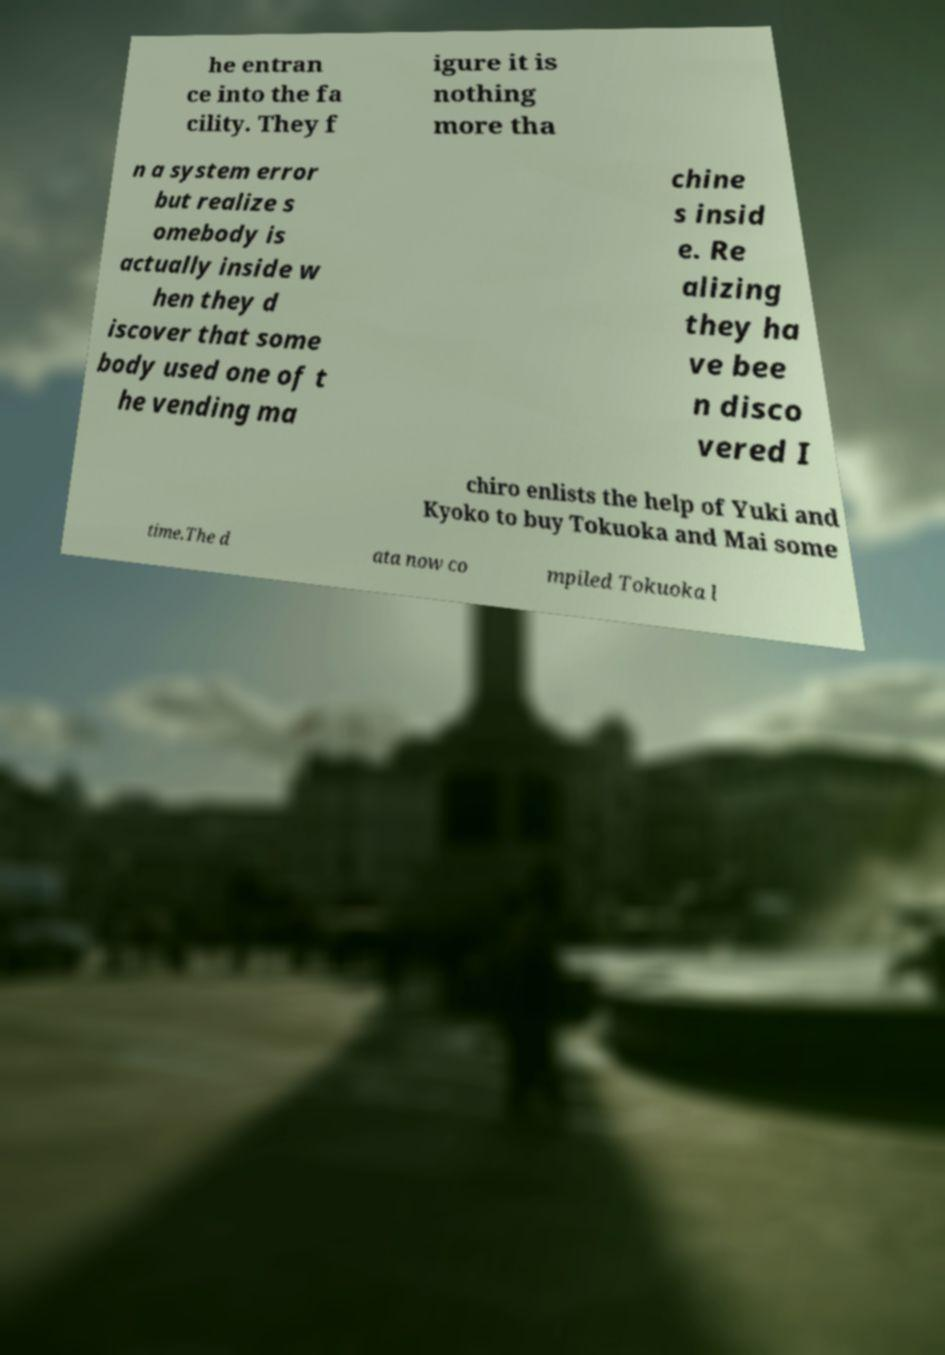Could you assist in decoding the text presented in this image and type it out clearly? he entran ce into the fa cility. They f igure it is nothing more tha n a system error but realize s omebody is actually inside w hen they d iscover that some body used one of t he vending ma chine s insid e. Re alizing they ha ve bee n disco vered I chiro enlists the help of Yuki and Kyoko to buy Tokuoka and Mai some time.The d ata now co mpiled Tokuoka l 